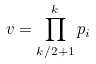<formula> <loc_0><loc_0><loc_500><loc_500>v = \prod _ { k / 2 + 1 } ^ { k } p _ { i }</formula> 